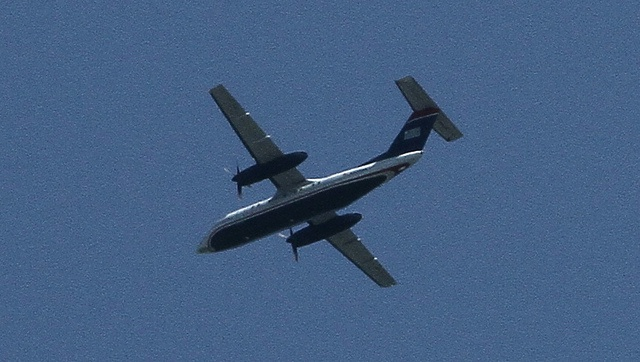Describe the objects in this image and their specific colors. I can see a airplane in gray, black, darkblue, and blue tones in this image. 